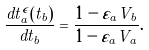<formula> <loc_0><loc_0><loc_500><loc_500>\frac { d t _ { a } ^ { \epsilon } ( t _ { b } ) } { d t _ { b } } = \frac { 1 - \varepsilon _ { a } V _ { b } } { 1 - \varepsilon _ { a } V _ { a } } .</formula> 